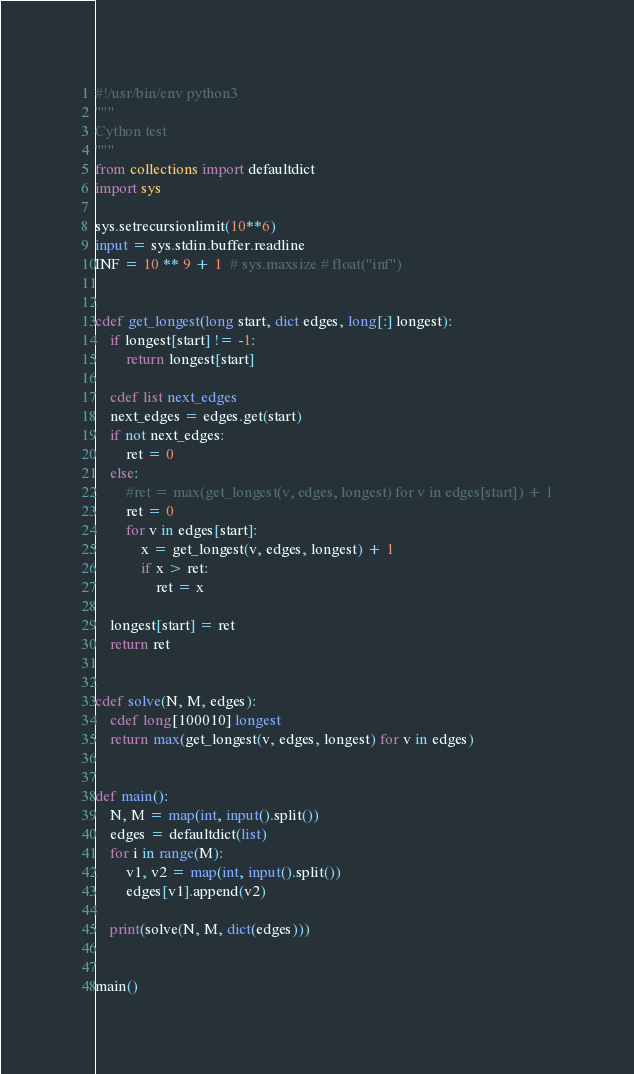<code> <loc_0><loc_0><loc_500><loc_500><_Cython_>#!/usr/bin/env python3
"""
Cython test
"""
from collections import defaultdict
import sys

sys.setrecursionlimit(10**6)
input = sys.stdin.buffer.readline
INF = 10 ** 9 + 1  # sys.maxsize # float("inf")


cdef get_longest(long start, dict edges, long[:] longest):
    if longest[start] != -1:
        return longest[start]

    cdef list next_edges
    next_edges = edges.get(start)
    if not next_edges:
        ret = 0
    else:
        #ret = max(get_longest(v, edges, longest) for v in edges[start]) + 1
        ret = 0
        for v in edges[start]:
            x = get_longest(v, edges, longest) + 1
            if x > ret:
                ret = x

    longest[start] = ret
    return ret


cdef solve(N, M, edges):
    cdef long[100010] longest
    return max(get_longest(v, edges, longest) for v in edges)


def main():
    N, M = map(int, input().split())
    edges = defaultdict(list)
    for i in range(M):
        v1, v2 = map(int, input().split())
        edges[v1].append(v2)

    print(solve(N, M, dict(edges)))


main()
</code> 